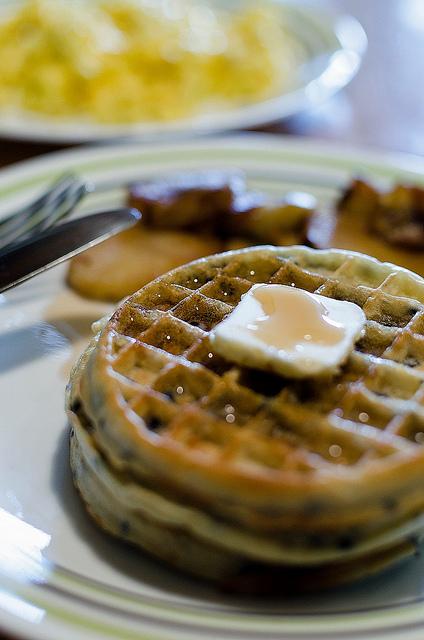How many waffles are shown?
Keep it brief. 3. What meal does this indicate?
Write a very short answer. Breakfast. What color is the plate?
Answer briefly. White. 